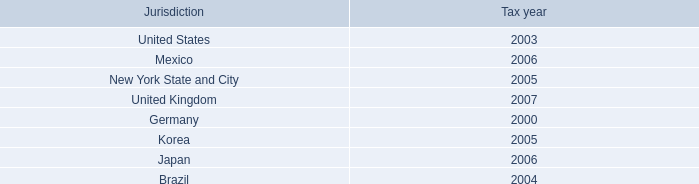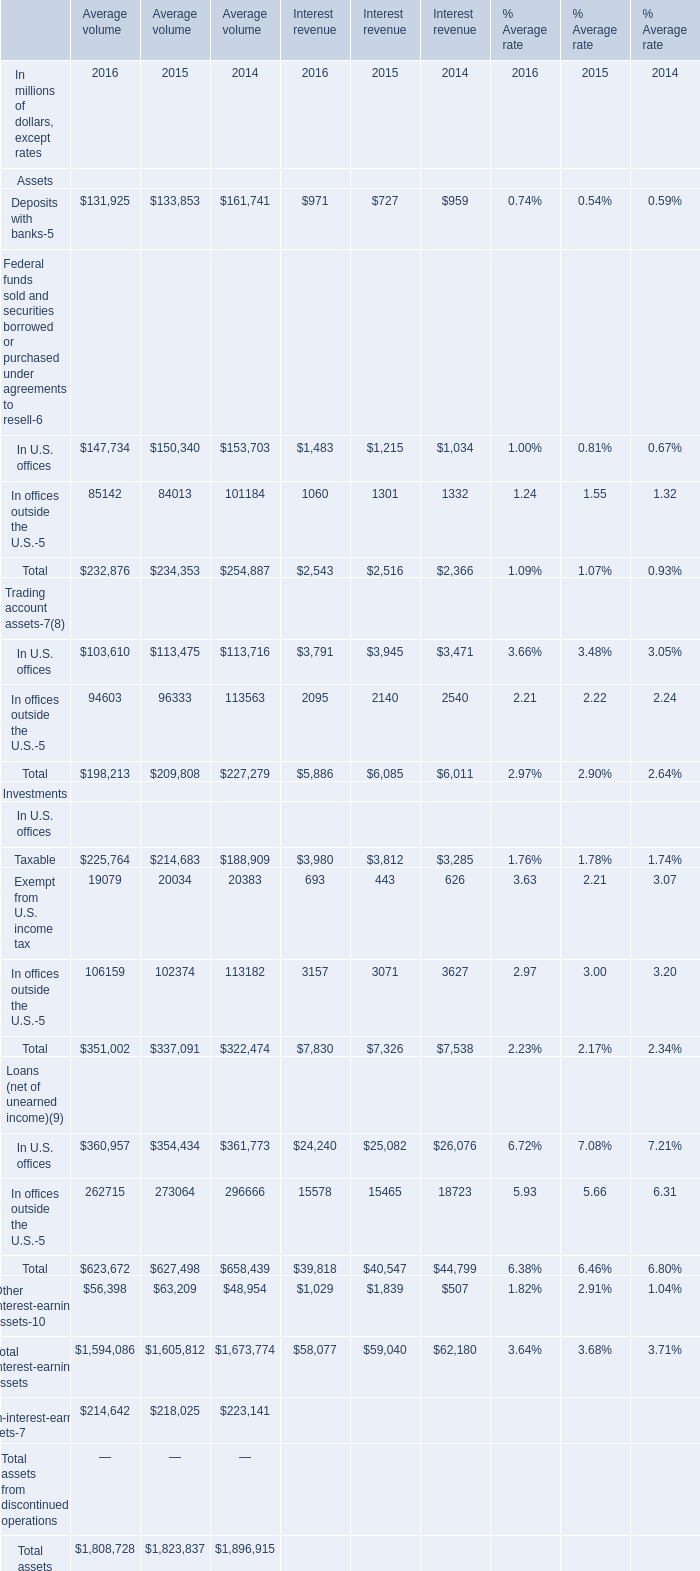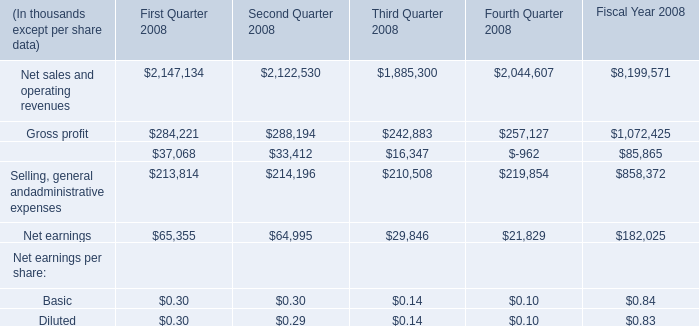What is the sum of Net earnings of Second Quarter 2008, and In U.S. offices Trading account assets of Average volume 2015 ? 
Computations: (64995.0 + 113475.0)
Answer: 178470.0. What is the average value of Federal funds sold and securities borrowed or purchased under agreements to resell in U.S. offices of Average volume in 2016,2015, and 2014? (in million) 
Computations: (((147734 + 150340) + 153703) / 3)
Answer: 150592.33333. 